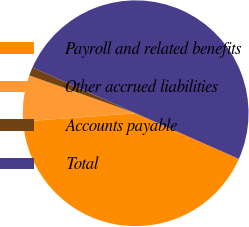Convert chart to OTSL. <chart><loc_0><loc_0><loc_500><loc_500><pie_chart><fcel>Payroll and related benefits<fcel>Other accrued liabilities<fcel>Accounts payable<fcel>Total<nl><fcel>42.21%<fcel>6.6%<fcel>1.2%<fcel>50.0%<nl></chart> 